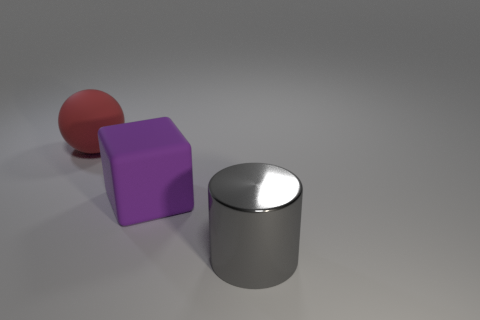Is there a big rubber ball that has the same color as the rubber block? No, there isn't a big rubber ball that shares the same color as the rubber block. In the image, there is a red rubber ball, a purple rubber block, and a silver cylindrical object, none of which share the same color. 